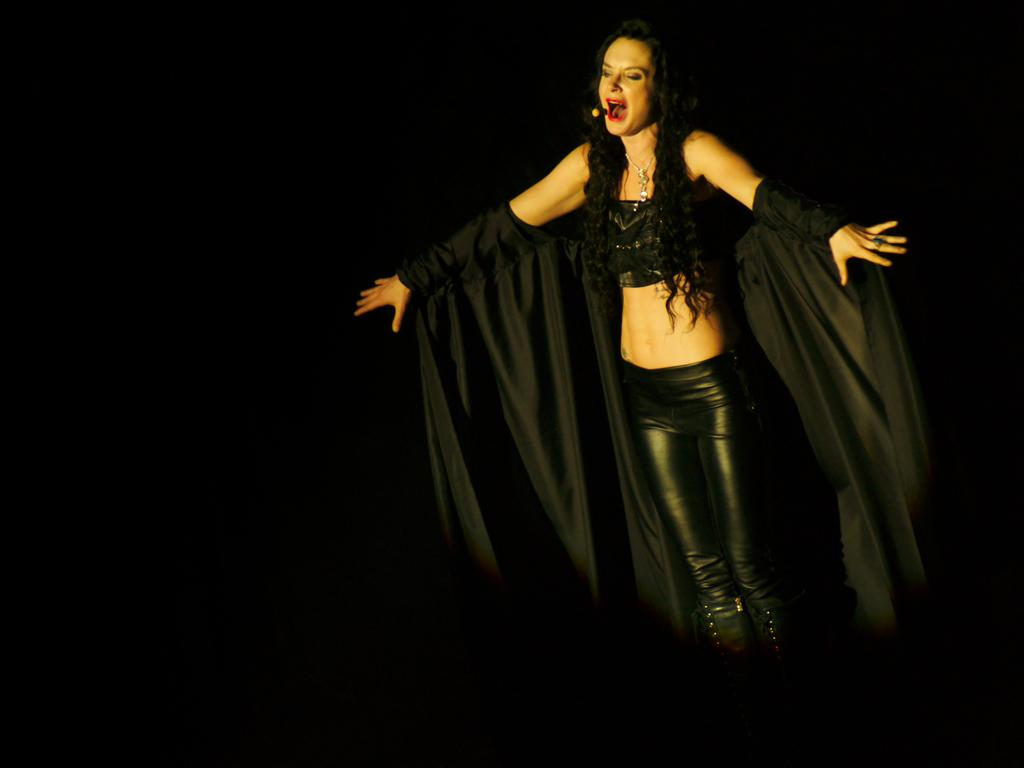Who is the main subject in the image? There is a woman in the image. Where is the woman located in the image? The woman is standing on a stage. What is the color of the background in the image? The background of the image is dark in color. What type of cheese is being served on the square table in the image? There is no cheese or square table present in the image. 